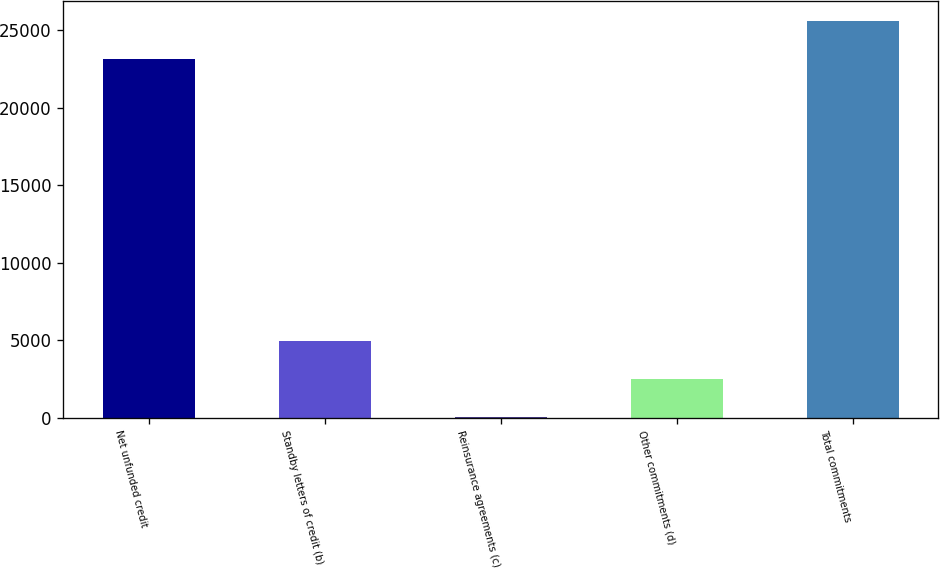Convert chart. <chart><loc_0><loc_0><loc_500><loc_500><bar_chart><fcel>Net unfunded credit<fcel>Standby letters of credit (b)<fcel>Reinsurance agreements (c)<fcel>Other commitments (d)<fcel>Total commitments<nl><fcel>23167<fcel>4921.8<fcel>50<fcel>2485.9<fcel>25602.9<nl></chart> 